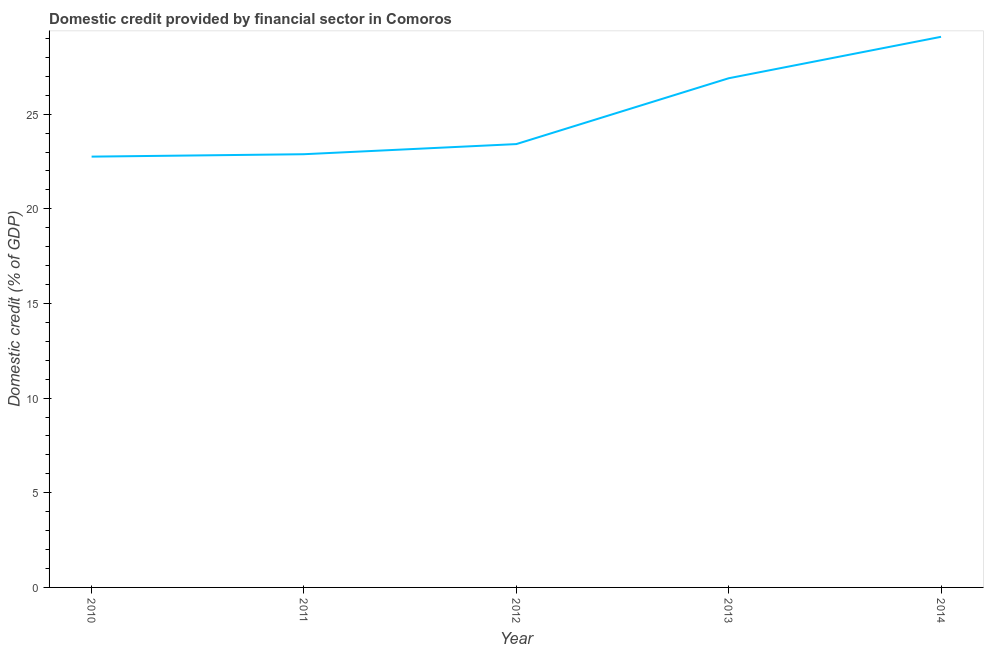What is the domestic credit provided by financial sector in 2012?
Provide a short and direct response. 23.42. Across all years, what is the maximum domestic credit provided by financial sector?
Keep it short and to the point. 29.09. Across all years, what is the minimum domestic credit provided by financial sector?
Offer a very short reply. 22.76. What is the sum of the domestic credit provided by financial sector?
Keep it short and to the point. 125.05. What is the difference between the domestic credit provided by financial sector in 2012 and 2013?
Offer a terse response. -3.48. What is the average domestic credit provided by financial sector per year?
Your answer should be compact. 25.01. What is the median domestic credit provided by financial sector?
Provide a short and direct response. 23.42. Do a majority of the years between 2013 and 2014 (inclusive) have domestic credit provided by financial sector greater than 28 %?
Your answer should be compact. No. What is the ratio of the domestic credit provided by financial sector in 2011 to that in 2013?
Make the answer very short. 0.85. Is the domestic credit provided by financial sector in 2012 less than that in 2013?
Your answer should be very brief. Yes. Is the difference between the domestic credit provided by financial sector in 2010 and 2012 greater than the difference between any two years?
Provide a succinct answer. No. What is the difference between the highest and the second highest domestic credit provided by financial sector?
Offer a very short reply. 2.19. What is the difference between the highest and the lowest domestic credit provided by financial sector?
Offer a terse response. 6.33. Does the domestic credit provided by financial sector monotonically increase over the years?
Your response must be concise. Yes. How many lines are there?
Make the answer very short. 1. How many years are there in the graph?
Provide a short and direct response. 5. What is the difference between two consecutive major ticks on the Y-axis?
Ensure brevity in your answer.  5. What is the title of the graph?
Provide a short and direct response. Domestic credit provided by financial sector in Comoros. What is the label or title of the Y-axis?
Offer a terse response. Domestic credit (% of GDP). What is the Domestic credit (% of GDP) of 2010?
Provide a succinct answer. 22.76. What is the Domestic credit (% of GDP) in 2011?
Make the answer very short. 22.89. What is the Domestic credit (% of GDP) of 2012?
Your answer should be compact. 23.42. What is the Domestic credit (% of GDP) in 2013?
Provide a succinct answer. 26.9. What is the Domestic credit (% of GDP) of 2014?
Provide a succinct answer. 29.09. What is the difference between the Domestic credit (% of GDP) in 2010 and 2011?
Offer a terse response. -0.13. What is the difference between the Domestic credit (% of GDP) in 2010 and 2012?
Make the answer very short. -0.66. What is the difference between the Domestic credit (% of GDP) in 2010 and 2013?
Provide a short and direct response. -4.14. What is the difference between the Domestic credit (% of GDP) in 2010 and 2014?
Offer a very short reply. -6.33. What is the difference between the Domestic credit (% of GDP) in 2011 and 2012?
Give a very brief answer. -0.53. What is the difference between the Domestic credit (% of GDP) in 2011 and 2013?
Make the answer very short. -4.01. What is the difference between the Domestic credit (% of GDP) in 2011 and 2014?
Provide a succinct answer. -6.2. What is the difference between the Domestic credit (% of GDP) in 2012 and 2013?
Make the answer very short. -3.48. What is the difference between the Domestic credit (% of GDP) in 2012 and 2014?
Provide a short and direct response. -5.67. What is the difference between the Domestic credit (% of GDP) in 2013 and 2014?
Offer a terse response. -2.19. What is the ratio of the Domestic credit (% of GDP) in 2010 to that in 2013?
Your answer should be compact. 0.85. What is the ratio of the Domestic credit (% of GDP) in 2010 to that in 2014?
Provide a succinct answer. 0.78. What is the ratio of the Domestic credit (% of GDP) in 2011 to that in 2012?
Keep it short and to the point. 0.98. What is the ratio of the Domestic credit (% of GDP) in 2011 to that in 2013?
Keep it short and to the point. 0.85. What is the ratio of the Domestic credit (% of GDP) in 2011 to that in 2014?
Your answer should be compact. 0.79. What is the ratio of the Domestic credit (% of GDP) in 2012 to that in 2013?
Give a very brief answer. 0.87. What is the ratio of the Domestic credit (% of GDP) in 2012 to that in 2014?
Provide a short and direct response. 0.81. What is the ratio of the Domestic credit (% of GDP) in 2013 to that in 2014?
Make the answer very short. 0.93. 